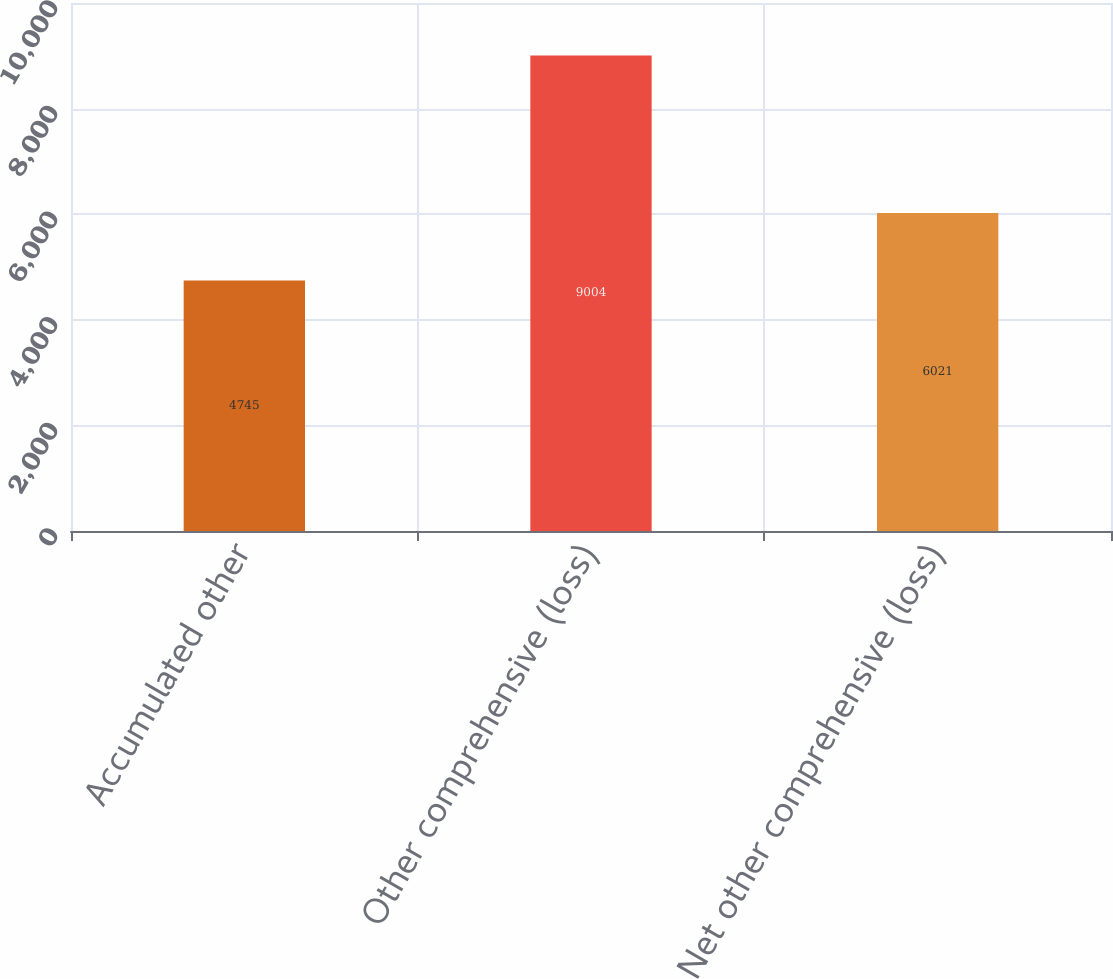<chart> <loc_0><loc_0><loc_500><loc_500><bar_chart><fcel>Accumulated other<fcel>Other comprehensive (loss)<fcel>Net other comprehensive (loss)<nl><fcel>4745<fcel>9004<fcel>6021<nl></chart> 